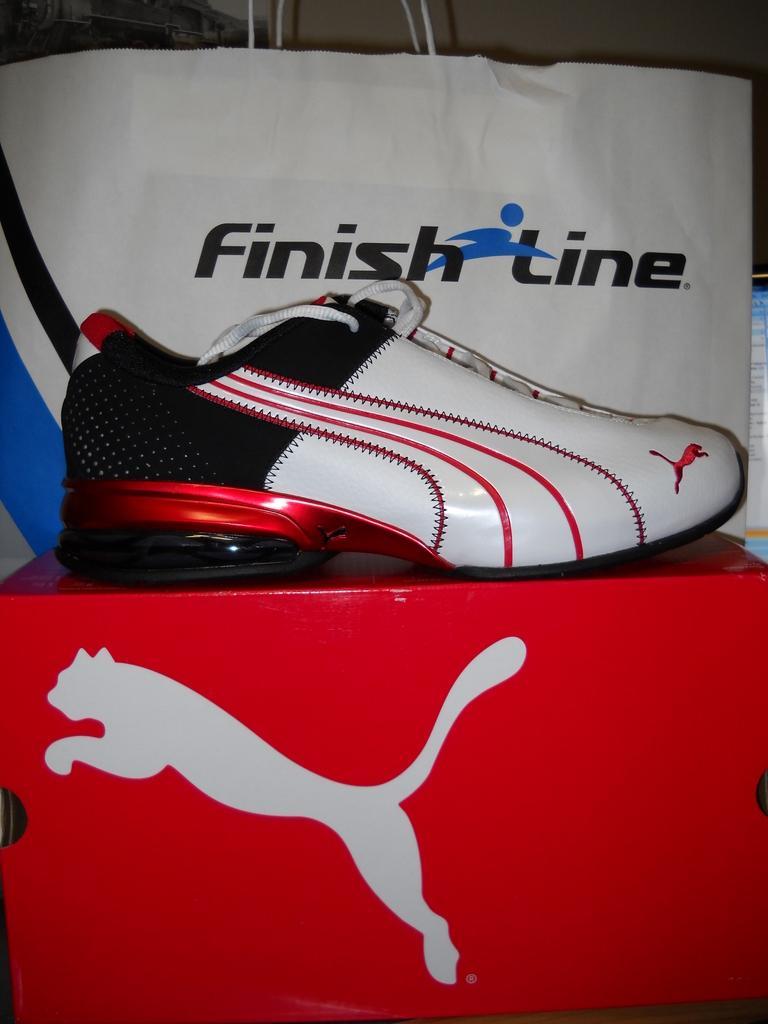Can you describe this image briefly? The picture consists of shoe, box and a cover. 